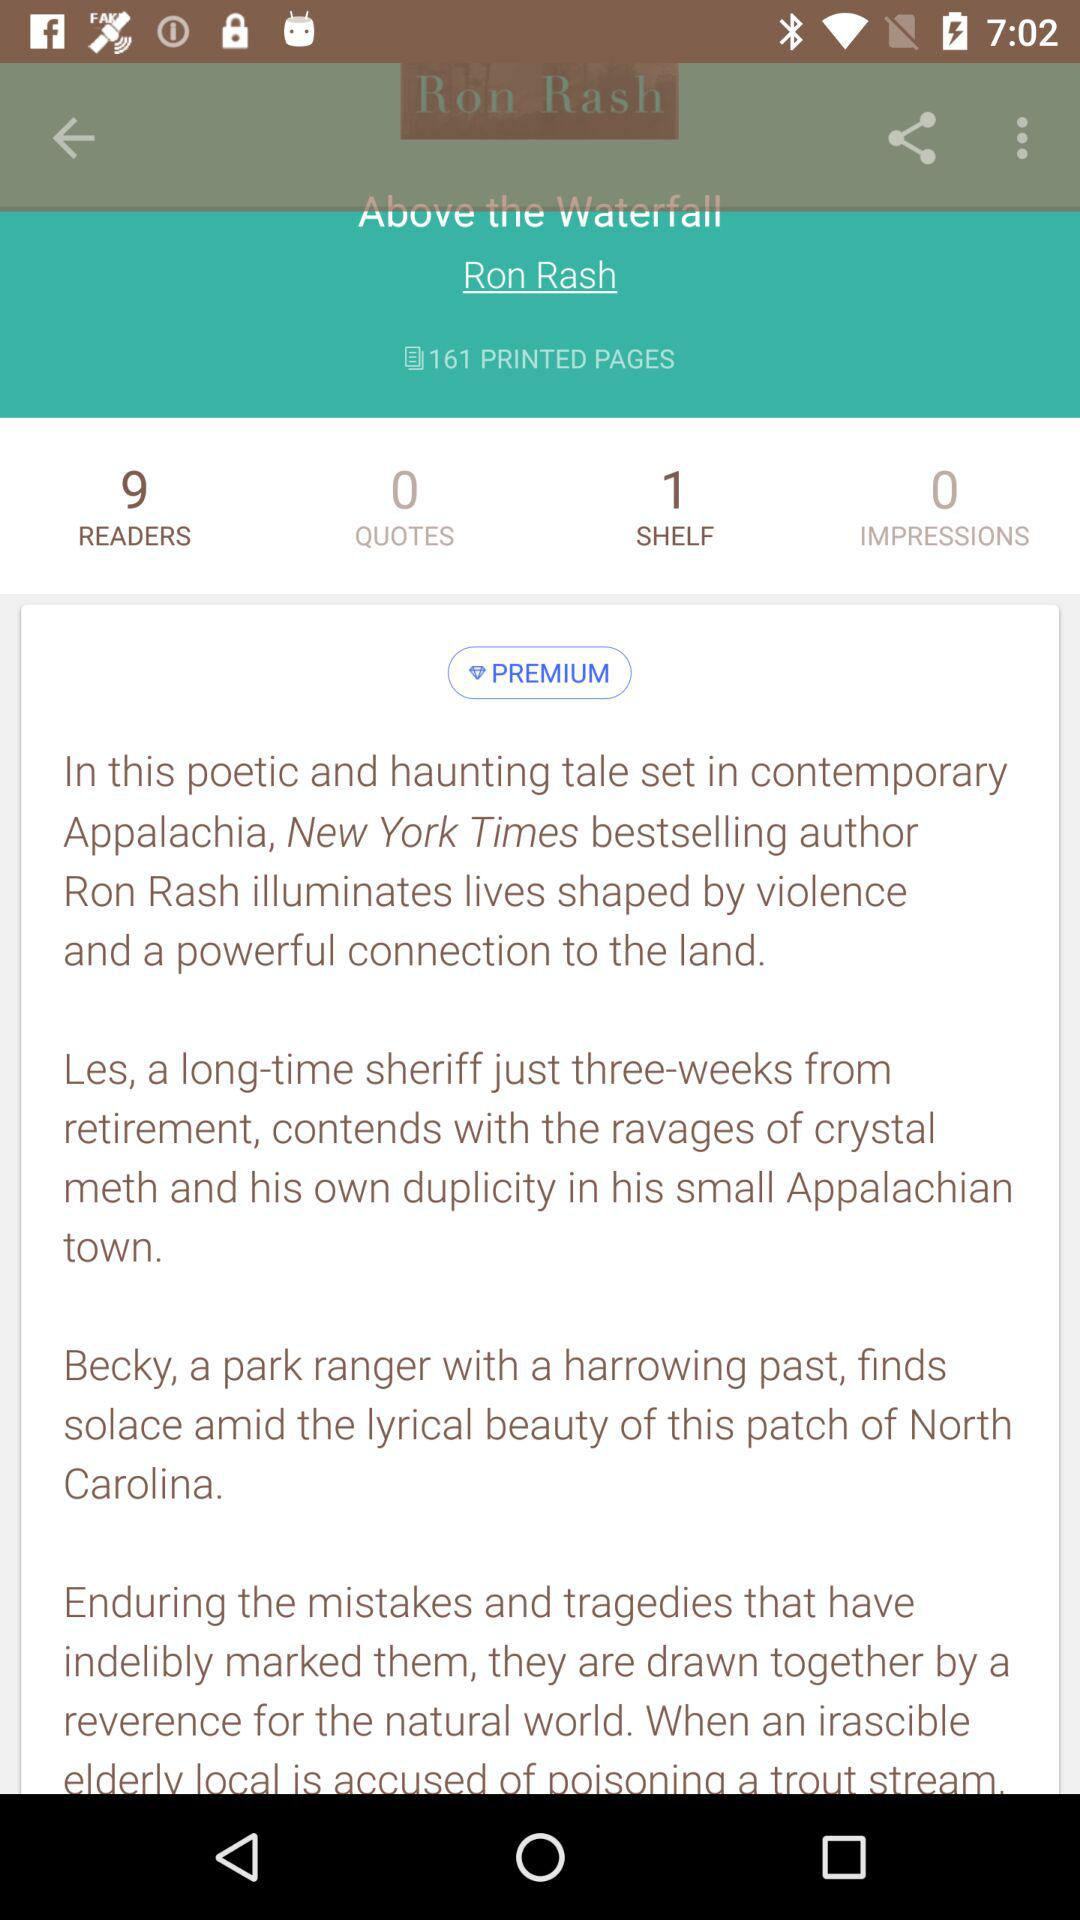How many pages are there in the book?
Answer the question using a single word or phrase. 161 